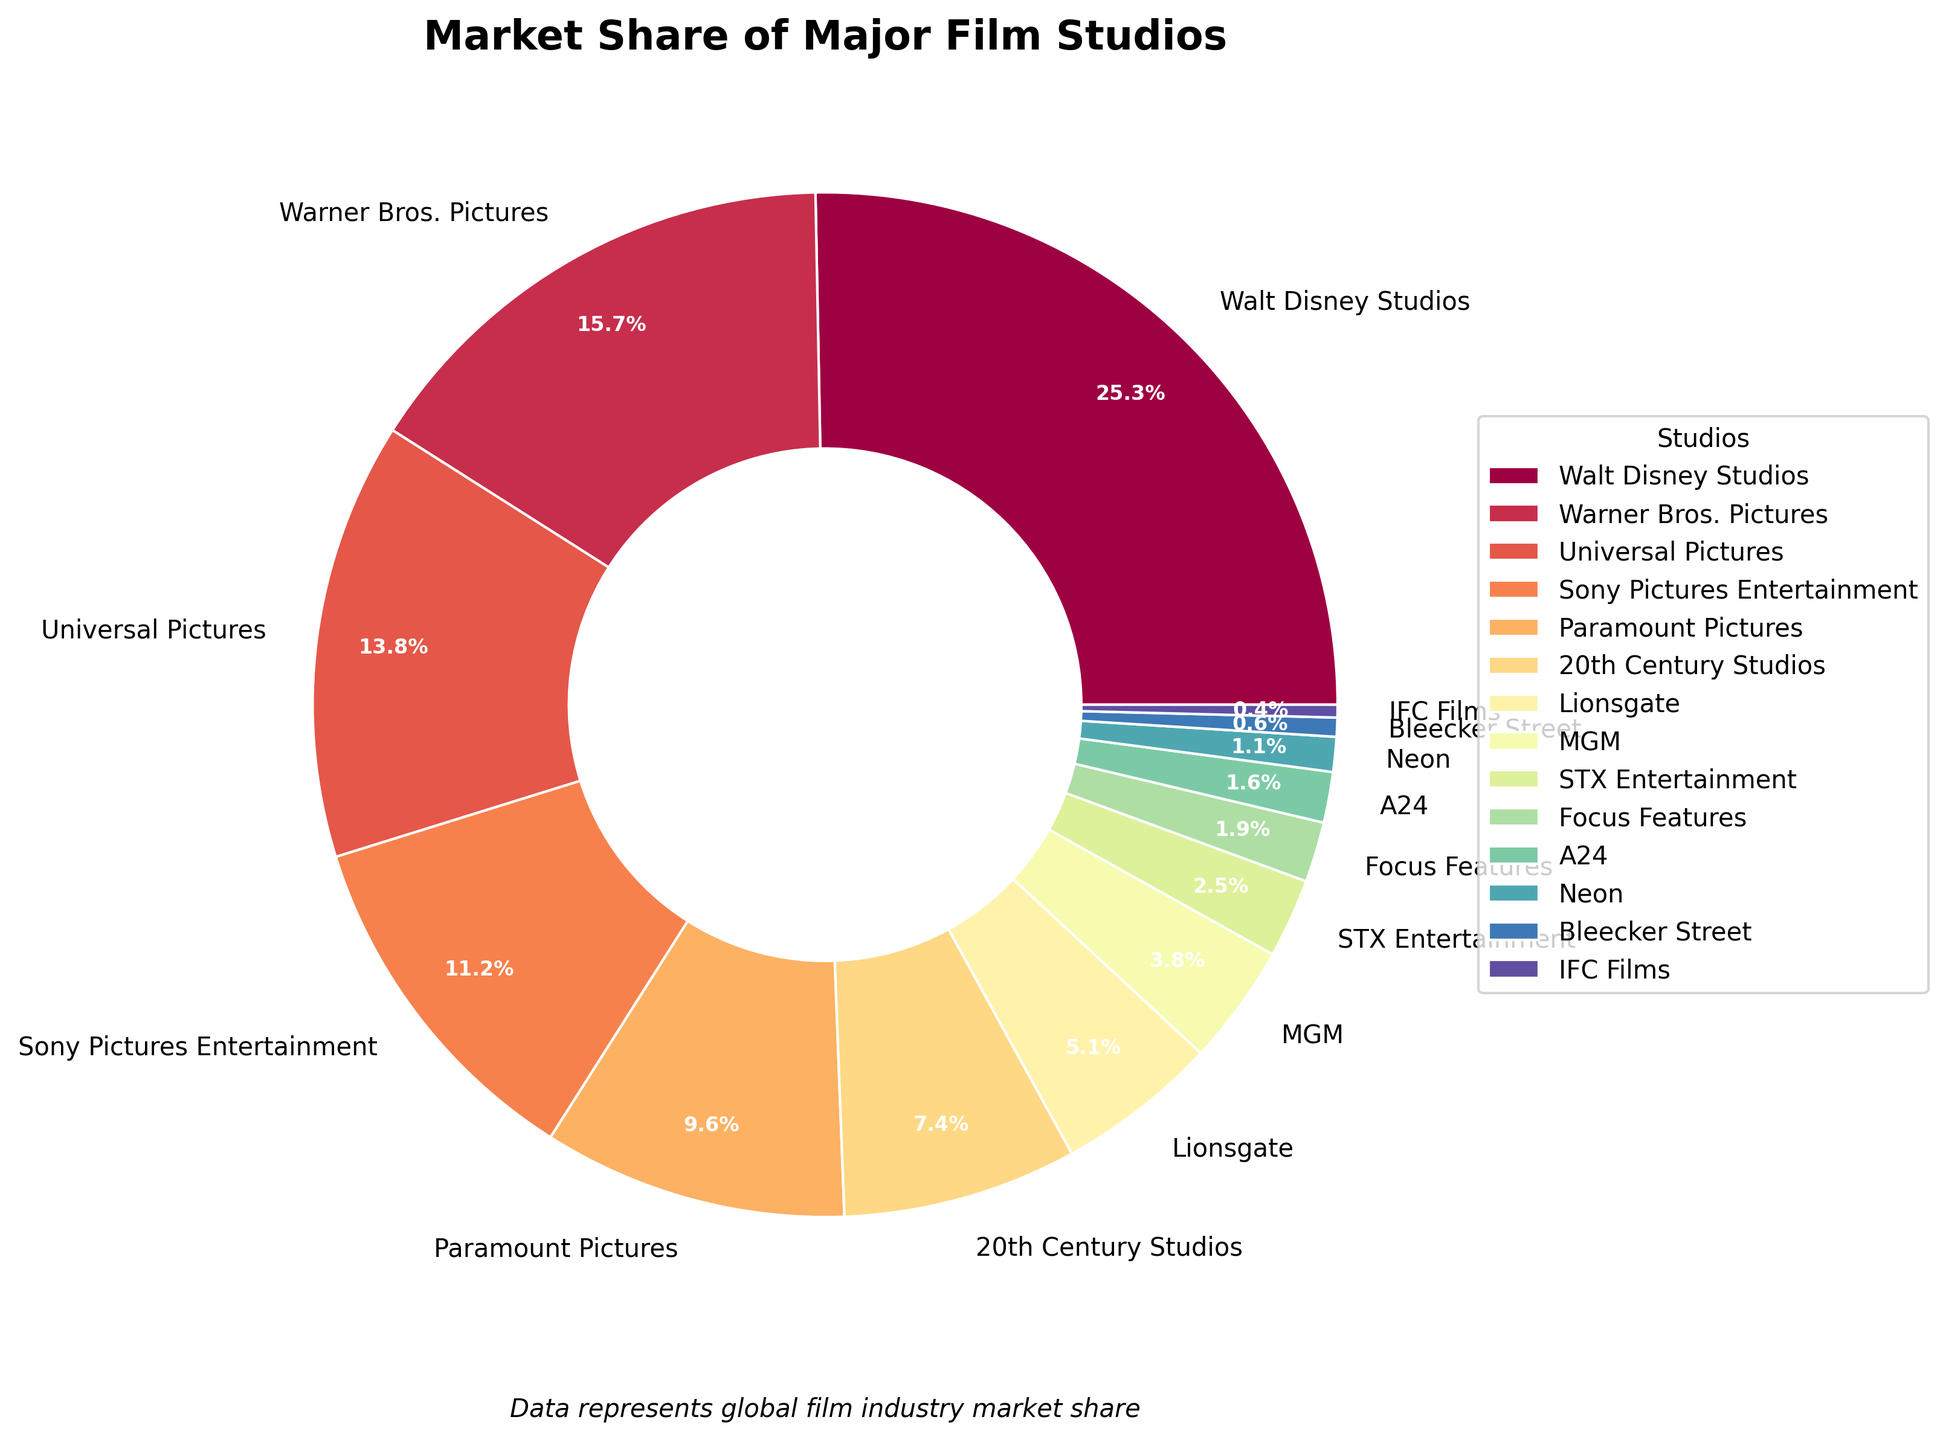which studio has the largest market share? Locate the largest segment in the pie chart and identify the corresponding label, which is Walt Disney Studios.
Answer: Walt Disney Studios What percentage of the market does Paramount Pictures hold? Locate the segment labeled Paramount Pictures and read the percentage value displayed on the segment.
Answer: 9.6% What is the combined market share of Universal Pictures and Sony Pictures Entertainment? Locate the segments labeled Universal Pictures and Sony Pictures Entertainment, then sum their percentages: 13.8% + 11.2%.
Answer: 25% Which studio has a larger market share: 20th Century Studios or Lionsgate? Compare the segments labeled 20th Century Studios and Lionsgate. 20th Century Studios has 7.4%, and Lionsgate has 5.1%, meaning 20th Century Studios has a larger share.
Answer: 20th Century Studios How does the market share of MGM compare to that of STX Entertainment? Compare the segments labeled MGM and STX Entertainment. MGM has a market share of 3.8%, and STX Entertainment has 2.5%; therefore, MGM has a larger share.
Answer: MGM What is the total market share of the studios with less than 2% each? Identify segments with market shares less than 2% (Focus Features, A24, Neon, Bleecker Street, IFC Films) and sum their percentages: 1.9% + 1.6% + 1.1% + 0.6% + 0.4% = 5.6%
Answer: 5.6% Which studios together capture more than 50% of the market share? Sum the market shares starting with the largest and stop when exceeding 50%: Walt Disney Studios (25.3%) + Warner Bros. Pictures (15.7%) + Universal Pictures (13.8%) = 54.8%.
Answer: Walt Disney Studios, Warner Bros. Pictures, Universal Pictures What is the difference in market share between the largest and smallest studio? Identify the largest (Walt Disney Studios, 25.3%) and the smallest (IFC Films, 0.4%) and subtract the smallest from the largest: 25.3% - 0.4% = 24.9%.
Answer: 24.9% What is the average market share of the top three studios? Locate the top three studios: Walt Disney Studios (25.3%), Warner Bros. Pictures (15.7%), and Universal Pictures (13.8%). Sum their percentages and divide by 3: (25.3 + 15.7 + 13.8) / 3 = 54.8 / 3 = 18.27.
Answer: 18.27% If you combined the market shares of Focus Features, A24, and Neon, which studio's market share would it surpass? Sum the market shares of Focus Features (1.9%), A24 (1.6%), and Neon (1.1%): 1.9% + 1.6% + 1.1% = 4.6%. Compare this with other studios; it surpasses MGM (3.8%).
Answer: MGM 